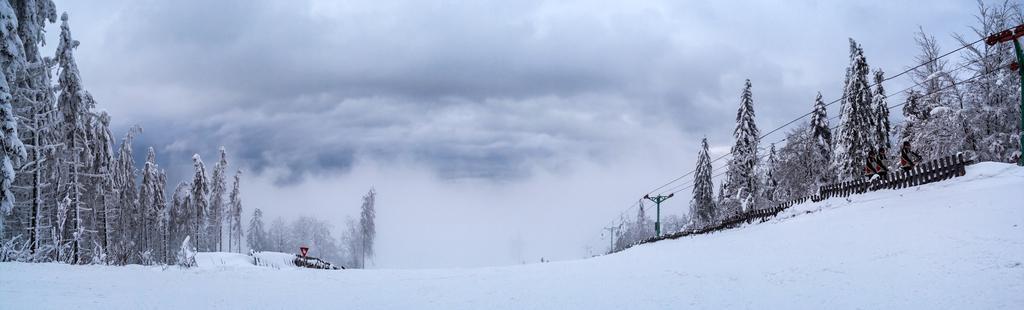Please provide a concise description of this image. In this image I can see the snow, few persons standing on the snow, the railing, few green colored poles, few wires and few trees. In the background I can see the sky. 